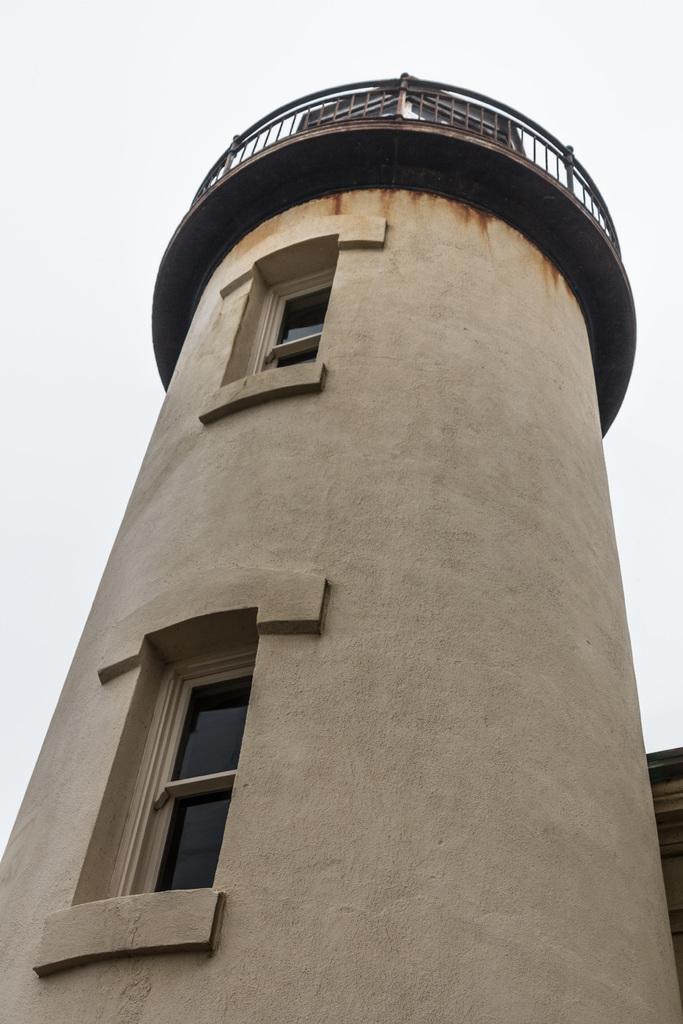Describe this image in one or two sentences. In the image there is a tall tower, it has two windows. 